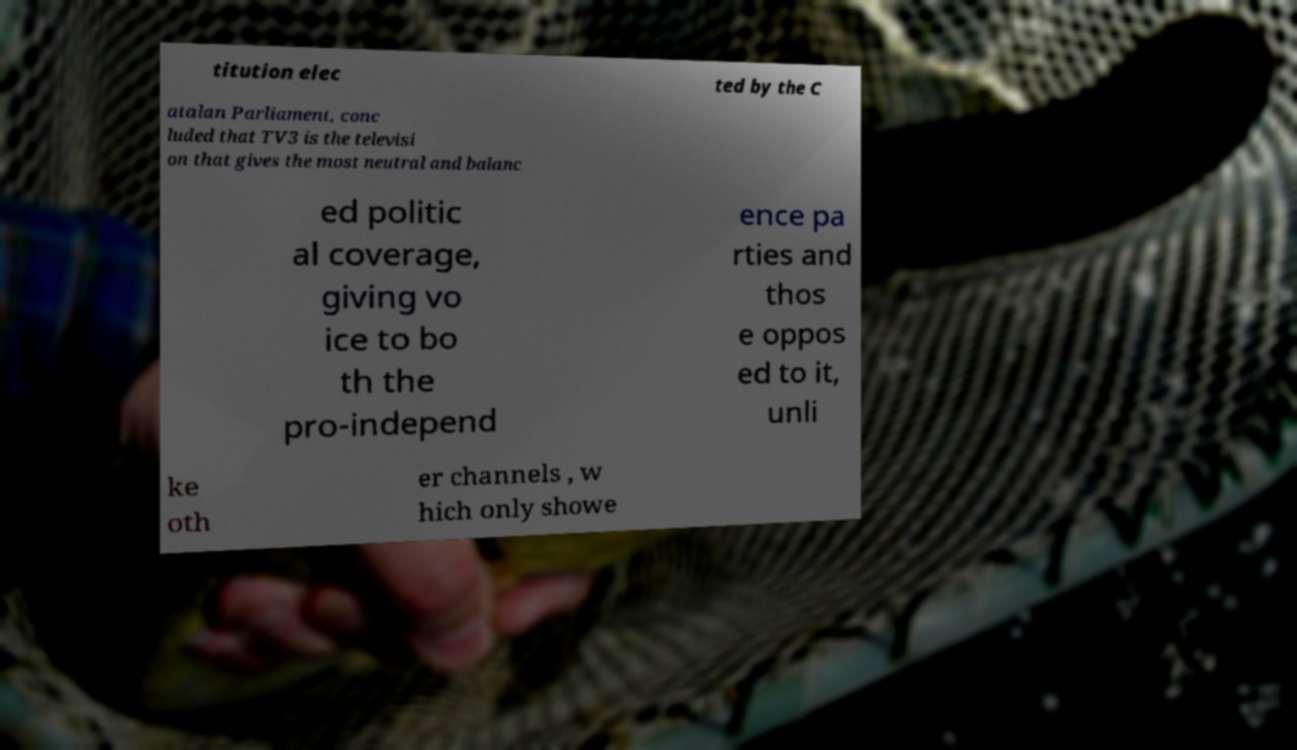Could you extract and type out the text from this image? titution elec ted by the C atalan Parliament, conc luded that TV3 is the televisi on that gives the most neutral and balanc ed politic al coverage, giving vo ice to bo th the pro-independ ence pa rties and thos e oppos ed to it, unli ke oth er channels , w hich only showe 